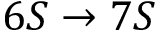<formula> <loc_0><loc_0><loc_500><loc_500>6 S \rightarrow 7 S</formula> 